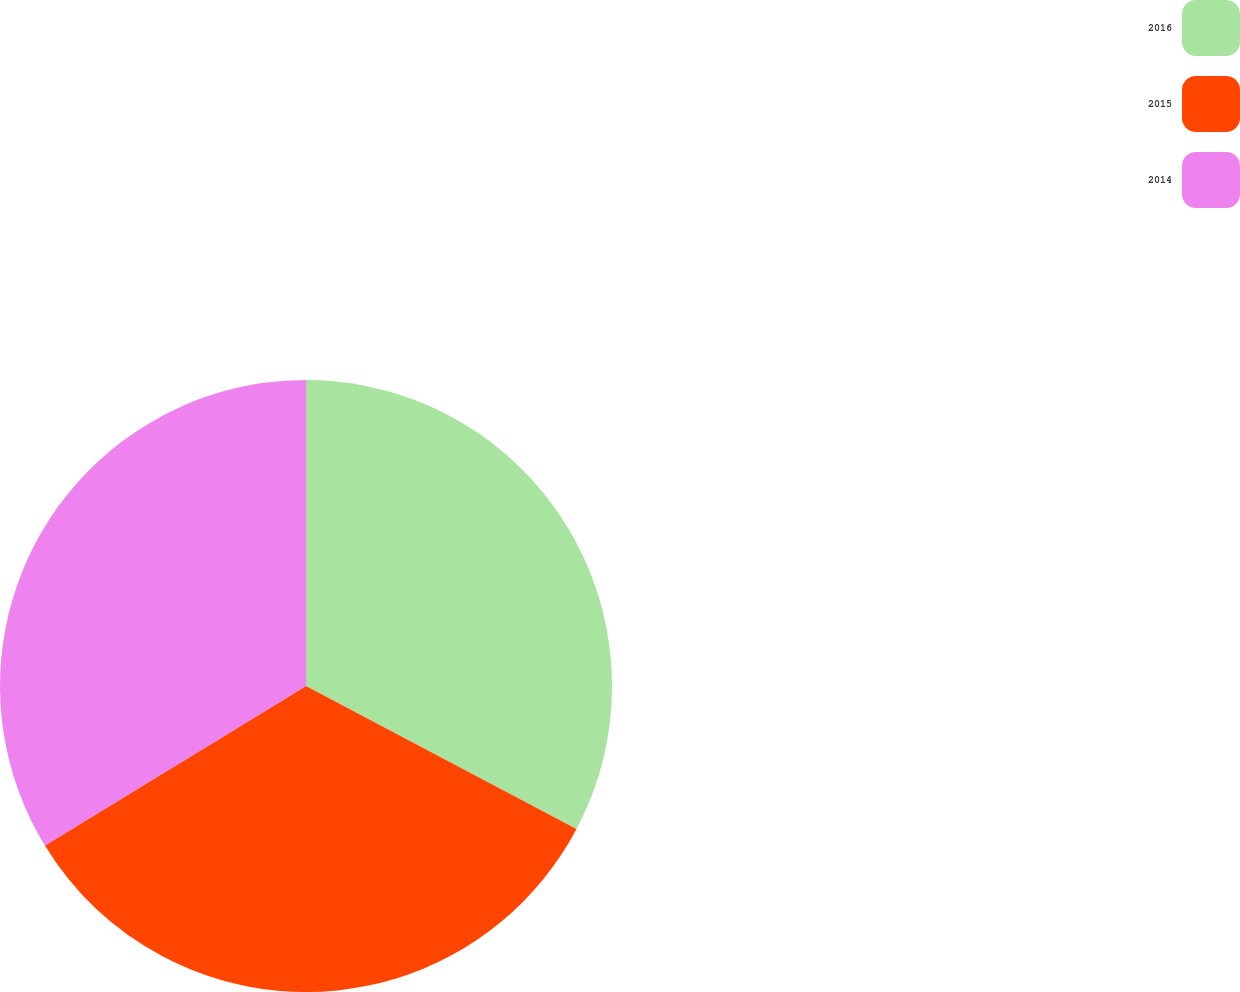Convert chart. <chart><loc_0><loc_0><loc_500><loc_500><pie_chart><fcel>2016<fcel>2015<fcel>2014<nl><fcel>32.74%<fcel>33.53%<fcel>33.73%<nl></chart> 